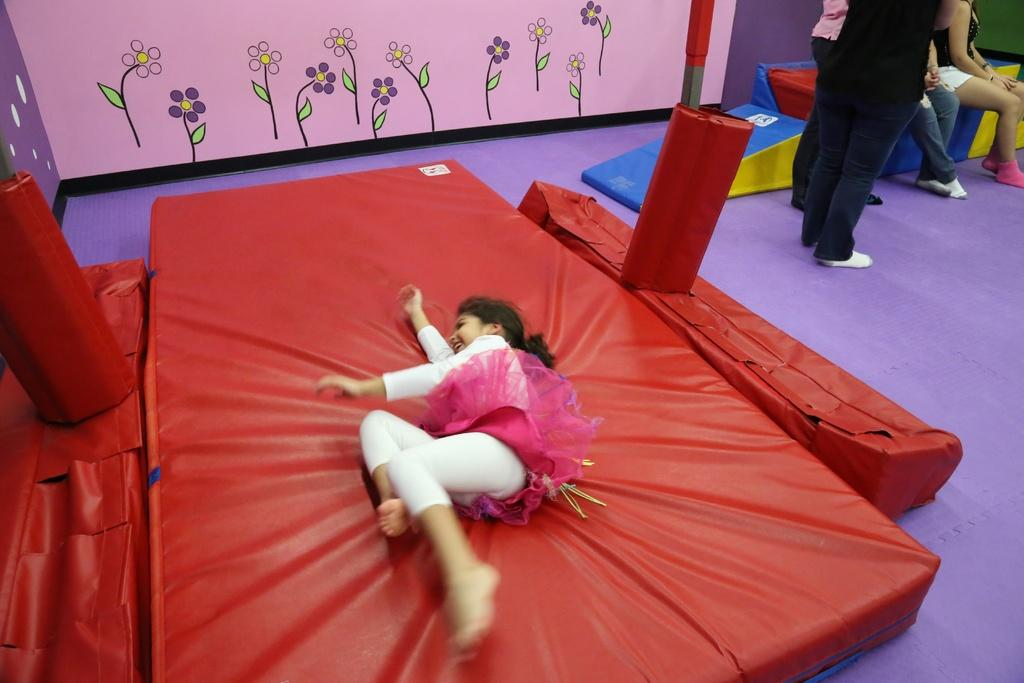What are the humans in the image doing? Some humans are sitting, while others are standing in the image. Can you describe the girl's position in the image? The girl is lying on the bed in the image. What activity is the girl engaged in? The girl is painting on the wall in the image. What type of yam is the girl using to paint the wall in the image? There is no yam present in the image; the girl is using a paintbrush or similar tool to paint the wall. 